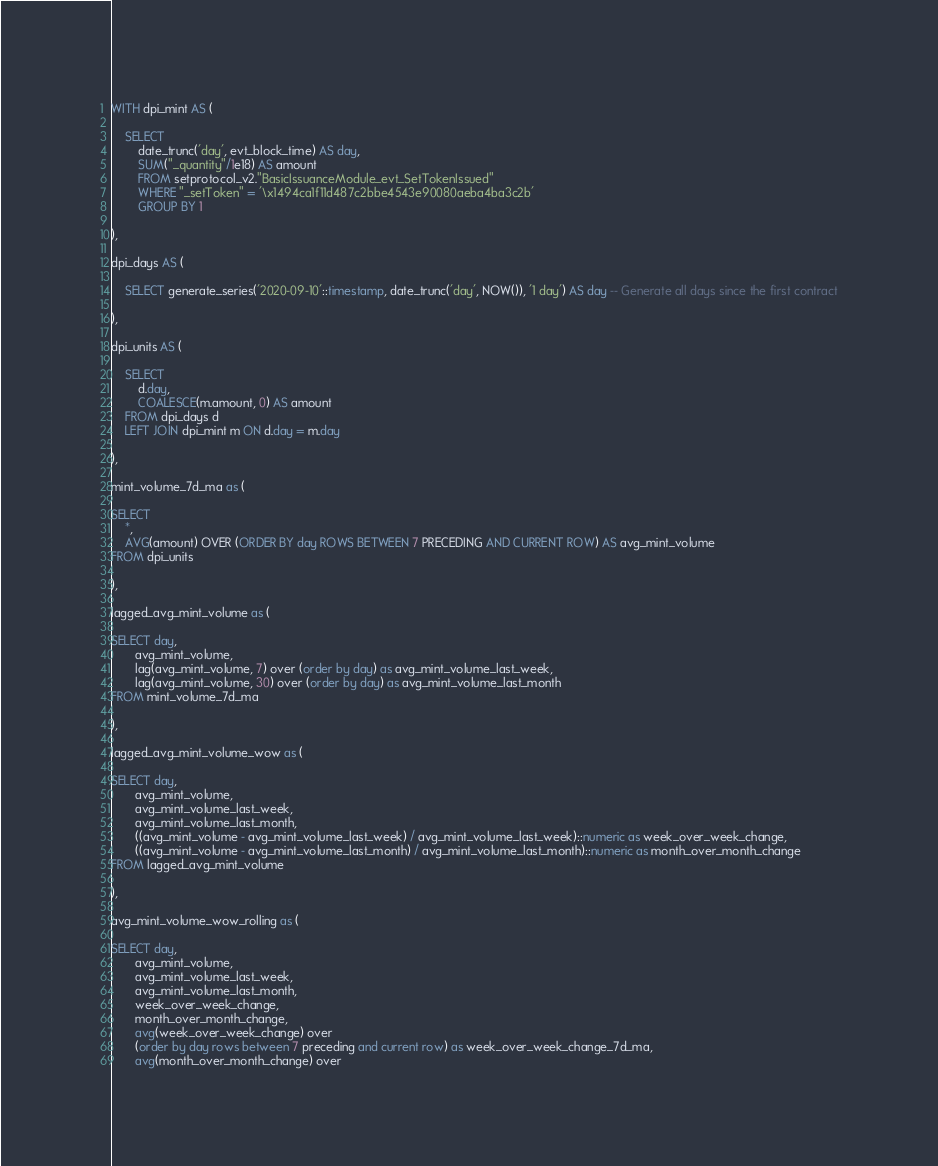<code> <loc_0><loc_0><loc_500><loc_500><_SQL_>WITH dpi_mint AS (

    SELECT 
        date_trunc('day', evt_block_time) AS day, 
        SUM("_quantity"/1e18) AS amount 
        FROM setprotocol_v2."BasicIssuanceModule_evt_SetTokenIssued"
        WHERE "_setToken" = '\x1494ca1f11d487c2bbe4543e90080aeba4ba3c2b'
        GROUP BY 1

),

dpi_days AS (
    
    SELECT generate_series('2020-09-10'::timestamp, date_trunc('day', NOW()), '1 day') AS day -- Generate all days since the first contract
    
),

dpi_units AS (

    SELECT
        d.day,
        COALESCE(m.amount, 0) AS amount
    FROM dpi_days d
    LEFT JOIN dpi_mint m ON d.day = m.day
    
),

mint_volume_7d_ma as (

SELECT 
    *,
    AVG(amount) OVER (ORDER BY day ROWS BETWEEN 7 PRECEDING AND CURRENT ROW) AS avg_mint_volume
FROM dpi_units

),

lagged_avg_mint_volume as (

SELECT day,
       avg_mint_volume,
       lag(avg_mint_volume, 7) over (order by day) as avg_mint_volume_last_week,
       lag(avg_mint_volume, 30) over (order by day) as avg_mint_volume_last_month
FROM mint_volume_7d_ma

),

lagged_avg_mint_volume_wow as (

SELECT day,
       avg_mint_volume,
       avg_mint_volume_last_week,
       avg_mint_volume_last_month,
       ((avg_mint_volume - avg_mint_volume_last_week) / avg_mint_volume_last_week)::numeric as week_over_week_change, 
       ((avg_mint_volume - avg_mint_volume_last_month) / avg_mint_volume_last_month)::numeric as month_over_month_change 
FROM lagged_avg_mint_volume

),

avg_mint_volume_wow_rolling as (

SELECT day,
       avg_mint_volume,
       avg_mint_volume_last_week,
       avg_mint_volume_last_month,
       week_over_week_change,
       month_over_month_change,
       avg(week_over_week_change) over 
       (order by day rows between 7 preceding and current row) as week_over_week_change_7d_ma,
       avg(month_over_month_change) over </code> 